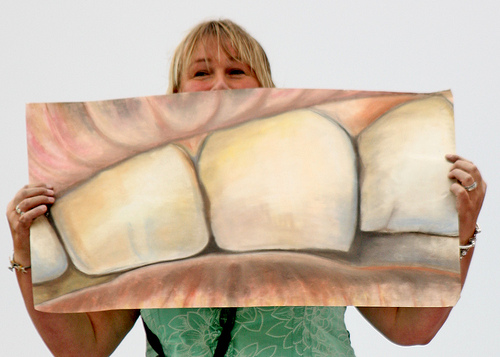<image>
Is there a woman behind the painting? Yes. From this viewpoint, the woman is positioned behind the painting, with the painting partially or fully occluding the woman. Is there a woman next to the art? No. The woman is not positioned next to the art. They are located in different areas of the scene. 